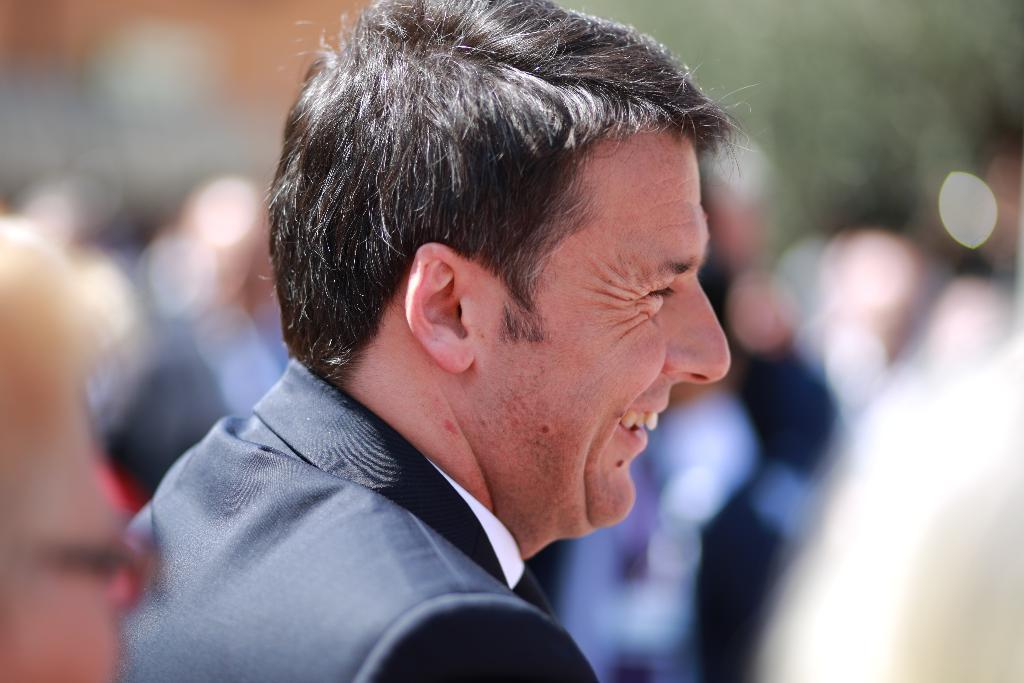What is present in the image? There is a man in the image. How is the man's expression in the image? The man is smiling in the image. Can you describe the visual quality of the area around the man? The area around the man is blurry in the image. What type of collar is the band wearing in the image? There is no band or collar present in the image; it features a man who is smiling. 